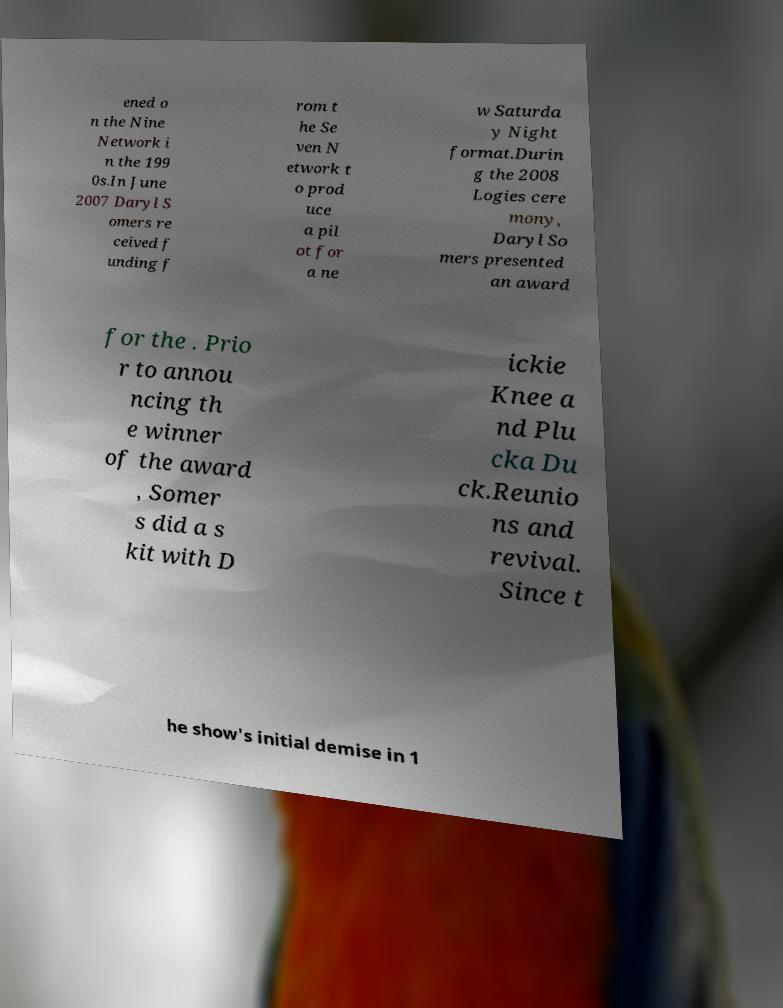I need the written content from this picture converted into text. Can you do that? ened o n the Nine Network i n the 199 0s.In June 2007 Daryl S omers re ceived f unding f rom t he Se ven N etwork t o prod uce a pil ot for a ne w Saturda y Night format.Durin g the 2008 Logies cere mony, Daryl So mers presented an award for the . Prio r to annou ncing th e winner of the award , Somer s did a s kit with D ickie Knee a nd Plu cka Du ck.Reunio ns and revival. Since t he show's initial demise in 1 